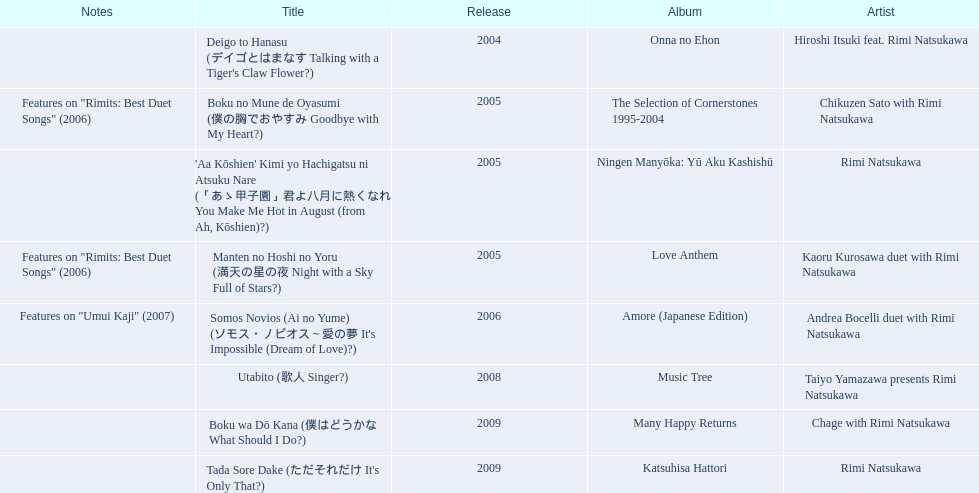What year was onna no ehon released? 2004. What year was music tree released? 2008. Which of the two was not released in 2004? Music Tree. 